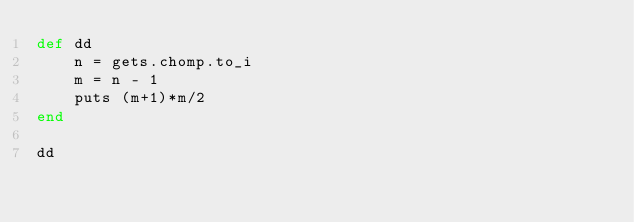<code> <loc_0><loc_0><loc_500><loc_500><_Ruby_>def dd
    n = gets.chomp.to_i
    m = n - 1
    puts (m+1)*m/2
end

dd
</code> 